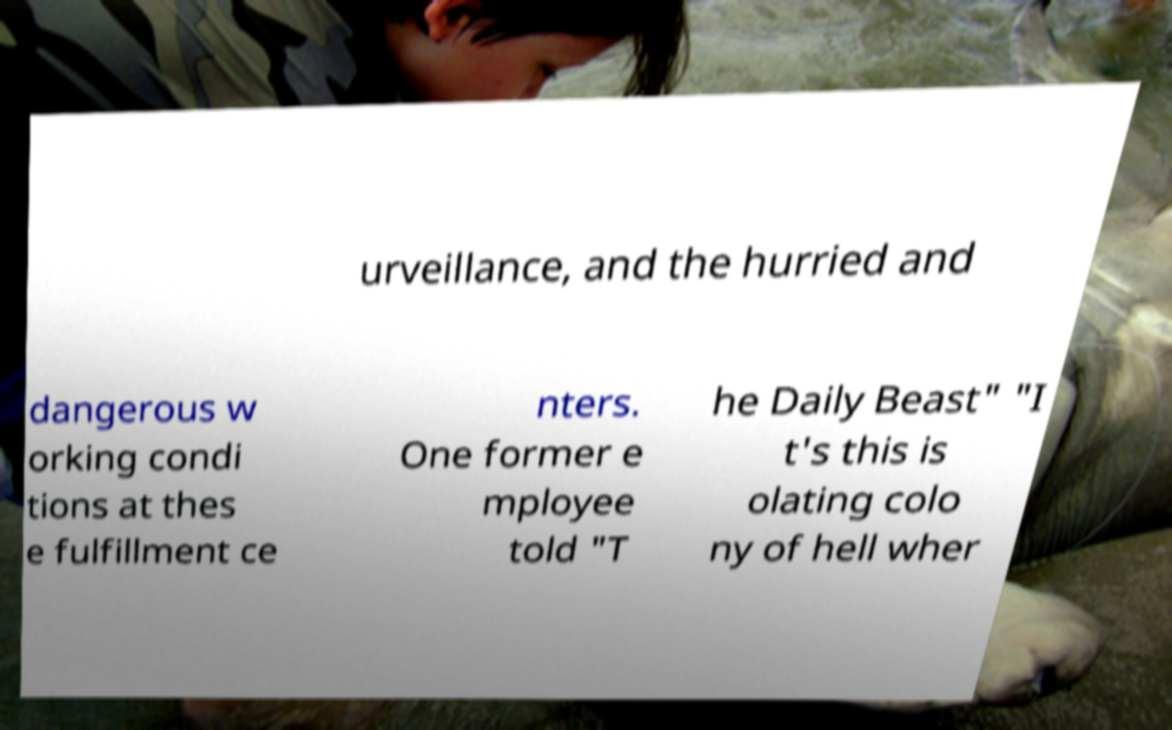There's text embedded in this image that I need extracted. Can you transcribe it verbatim? urveillance, and the hurried and dangerous w orking condi tions at thes e fulfillment ce nters. One former e mployee told "T he Daily Beast" "I t's this is olating colo ny of hell wher 